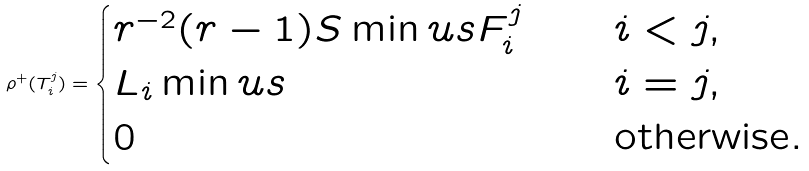<formula> <loc_0><loc_0><loc_500><loc_500>\rho ^ { + } ( T _ { i } ^ { j } ) = \begin{cases} r ^ { - 2 } ( r - 1 ) S \min u s F _ { i } ^ { j } \quad & i < j , \\ L _ { i } \min u s \quad & i = j , \\ 0 \quad & \text {otherwise} . \end{cases}</formula> 